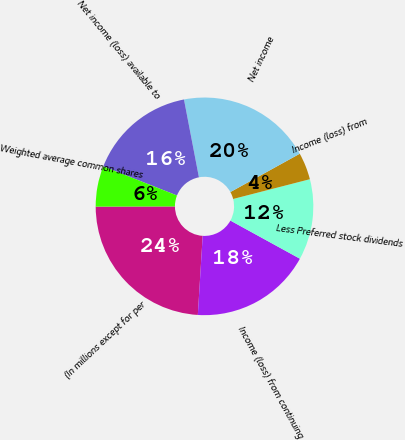Convert chart to OTSL. <chart><loc_0><loc_0><loc_500><loc_500><pie_chart><fcel>(In millions except for per<fcel>Income (loss) from continuing<fcel>Less Preferred stock dividends<fcel>Income (loss) from<fcel>Net income<fcel>Net income (loss) available to<fcel>Weighted average common shares<nl><fcel>23.98%<fcel>17.99%<fcel>12.0%<fcel>4.02%<fcel>19.99%<fcel>16.0%<fcel>6.02%<nl></chart> 